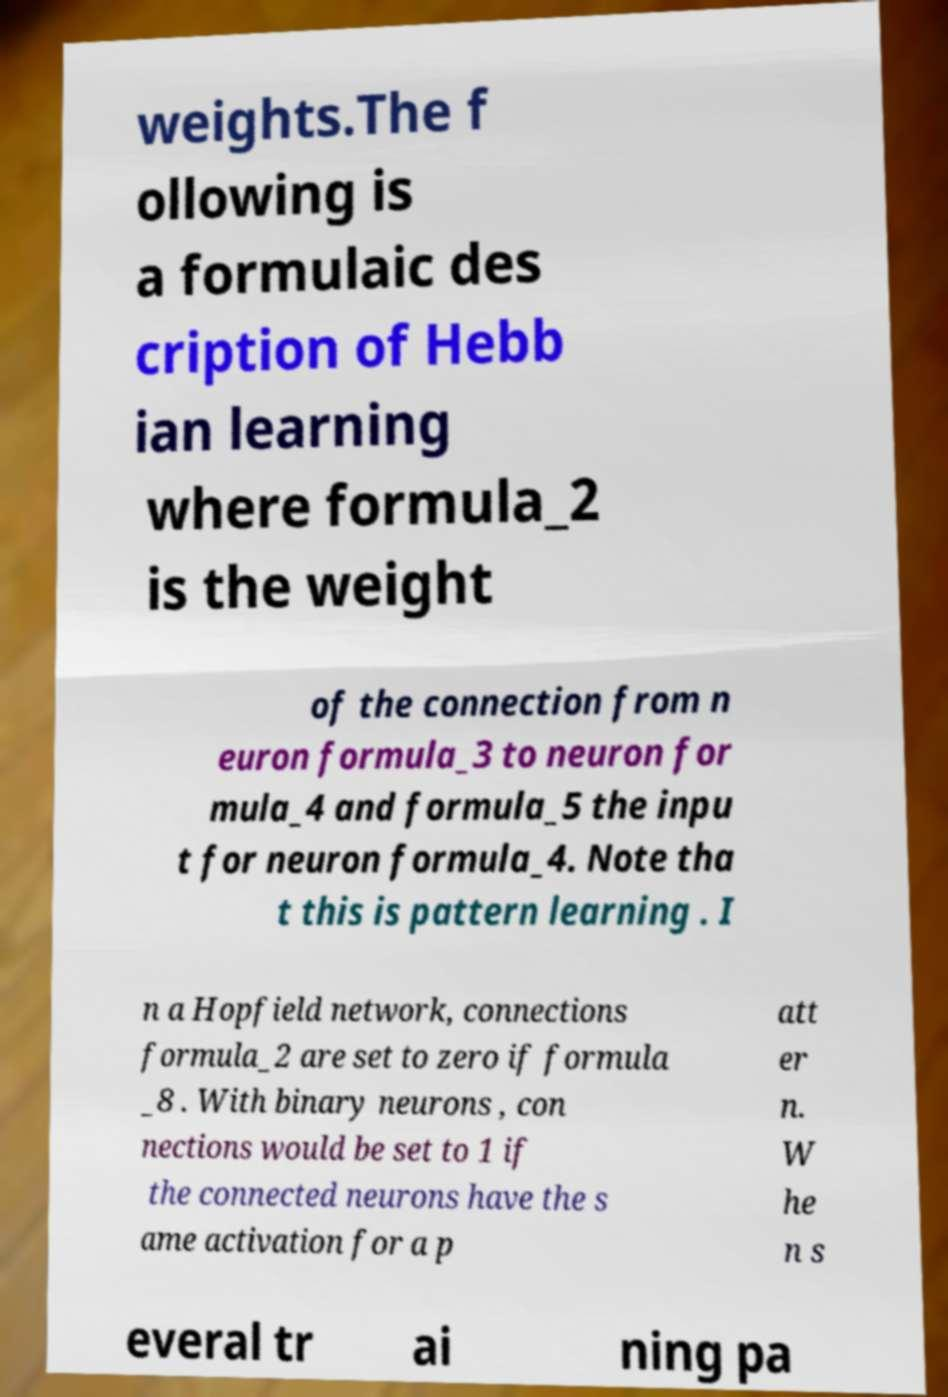Could you extract and type out the text from this image? weights.The f ollowing is a formulaic des cription of Hebb ian learning where formula_2 is the weight of the connection from n euron formula_3 to neuron for mula_4 and formula_5 the inpu t for neuron formula_4. Note tha t this is pattern learning . I n a Hopfield network, connections formula_2 are set to zero if formula _8 . With binary neurons , con nections would be set to 1 if the connected neurons have the s ame activation for a p att er n. W he n s everal tr ai ning pa 